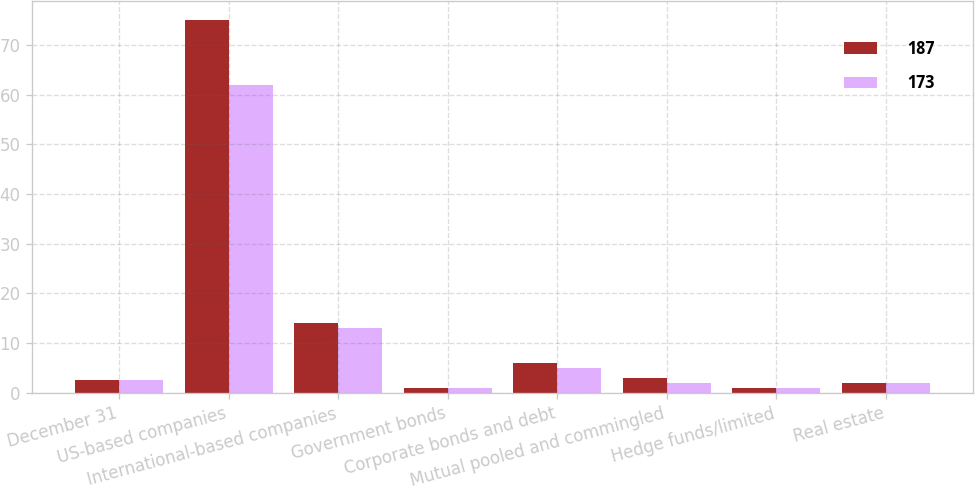Convert chart to OTSL. <chart><loc_0><loc_0><loc_500><loc_500><stacked_bar_chart><ecel><fcel>December 31<fcel>US-based companies<fcel>International-based companies<fcel>Government bonds<fcel>Corporate bonds and debt<fcel>Mutual pooled and commingled<fcel>Hedge funds/limited<fcel>Real estate<nl><fcel>187<fcel>2.5<fcel>75<fcel>14<fcel>1<fcel>6<fcel>3<fcel>1<fcel>2<nl><fcel>173<fcel>2.5<fcel>62<fcel>13<fcel>1<fcel>5<fcel>2<fcel>1<fcel>2<nl></chart> 